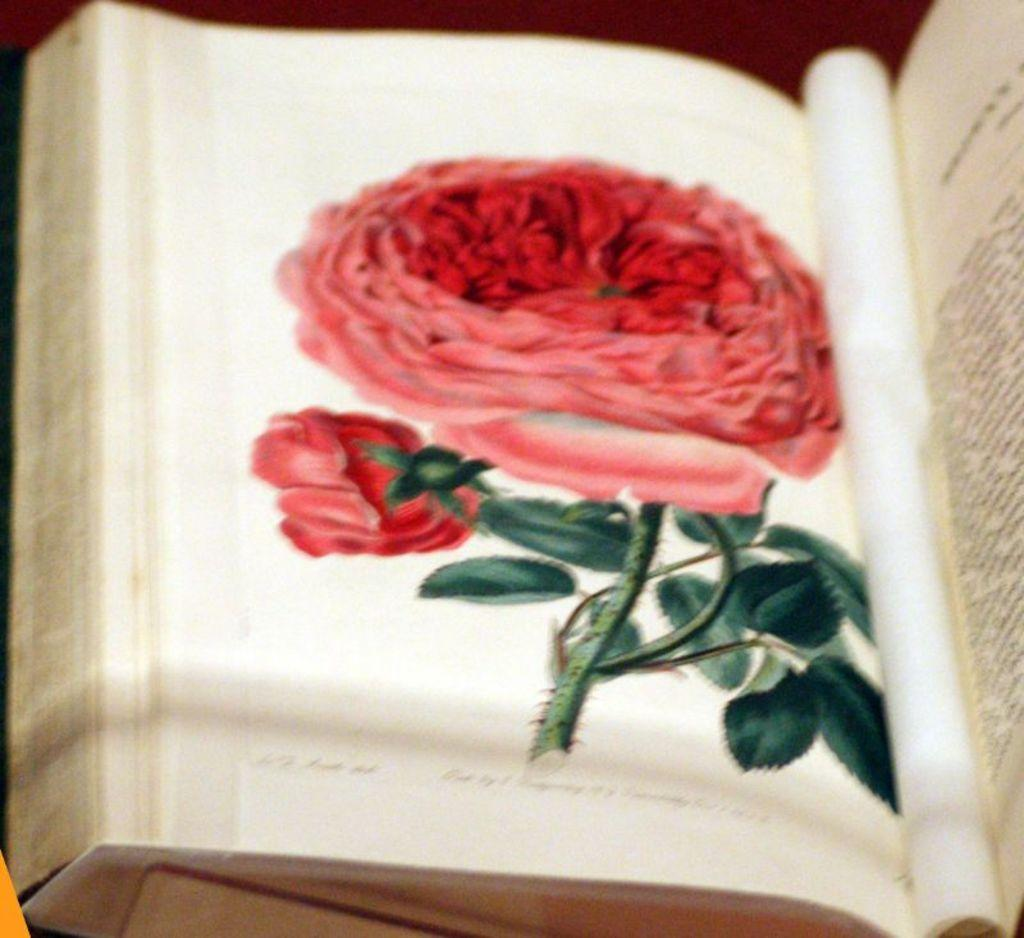What is the main subject of the image? The main subject of the image is a book. What can be seen on the paper inside the book? There is a rose flower on the paper in the book. Is there any text visible in the image? Yes, there is text on the paper on the right side of the book. How does the earthquake affect the book in the image? There is no earthquake present in the image, so its effects cannot be observed. What type of collar is visible on the book in the image? There is no collar present in the image; it is a book with a rose flower and text on the paper. 